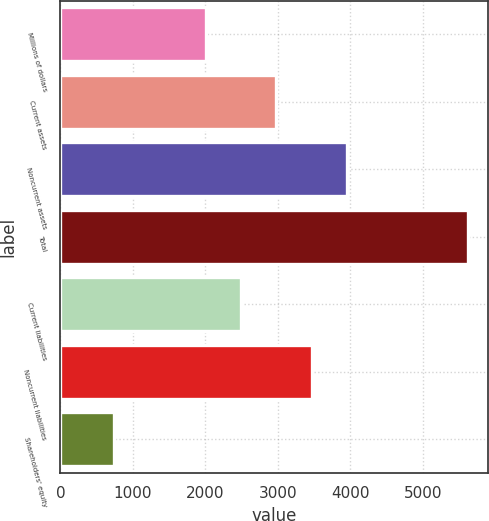Convert chart. <chart><loc_0><loc_0><loc_500><loc_500><bar_chart><fcel>Millions of dollars<fcel>Current assets<fcel>Noncurrent assets<fcel>Total<fcel>Current liabilities<fcel>Noncurrent liabilities<fcel>Shareholders' equity<nl><fcel>2004<fcel>2980.2<fcel>3956.4<fcel>5616<fcel>2492.1<fcel>3468.3<fcel>735<nl></chart> 